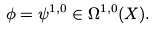<formula> <loc_0><loc_0><loc_500><loc_500>\phi = \psi ^ { 1 , 0 } \in \Omega ^ { 1 , 0 } ( X ) .</formula> 